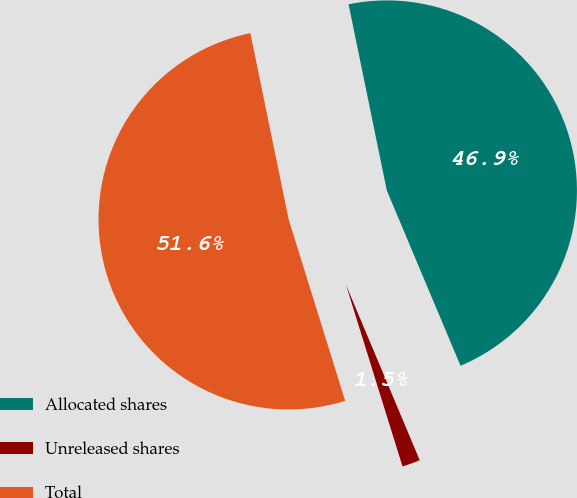Convert chart. <chart><loc_0><loc_0><loc_500><loc_500><pie_chart><fcel>Allocated shares<fcel>Unreleased shares<fcel>Total<nl><fcel>46.89%<fcel>1.53%<fcel>51.58%<nl></chart> 